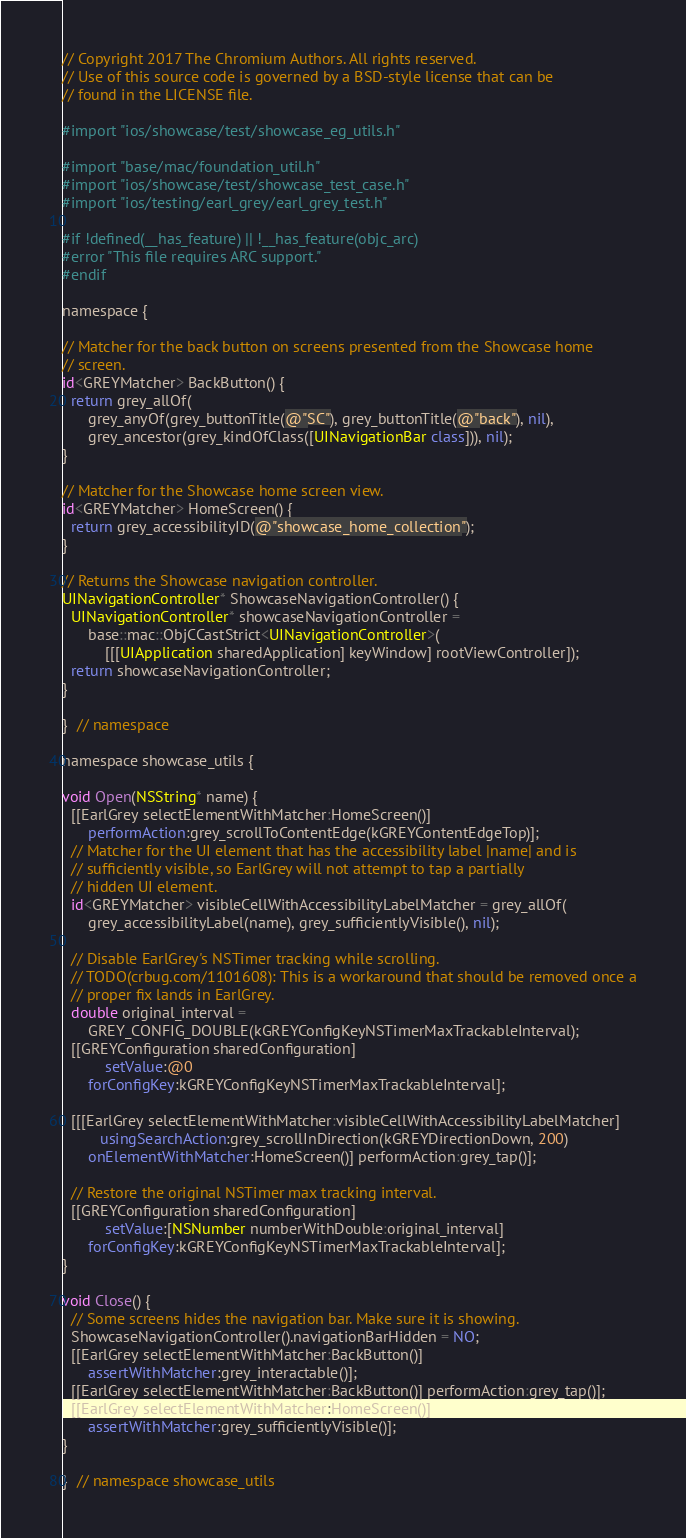<code> <loc_0><loc_0><loc_500><loc_500><_ObjectiveC_>// Copyright 2017 The Chromium Authors. All rights reserved.
// Use of this source code is governed by a BSD-style license that can be
// found in the LICENSE file.

#import "ios/showcase/test/showcase_eg_utils.h"

#import "base/mac/foundation_util.h"
#import "ios/showcase/test/showcase_test_case.h"
#import "ios/testing/earl_grey/earl_grey_test.h"

#if !defined(__has_feature) || !__has_feature(objc_arc)
#error "This file requires ARC support."
#endif

namespace {

// Matcher for the back button on screens presented from the Showcase home
// screen.
id<GREYMatcher> BackButton() {
  return grey_allOf(
      grey_anyOf(grey_buttonTitle(@"SC"), grey_buttonTitle(@"back"), nil),
      grey_ancestor(grey_kindOfClass([UINavigationBar class])), nil);
}

// Matcher for the Showcase home screen view.
id<GREYMatcher> HomeScreen() {
  return grey_accessibilityID(@"showcase_home_collection");
}

// Returns the Showcase navigation controller.
UINavigationController* ShowcaseNavigationController() {
  UINavigationController* showcaseNavigationController =
      base::mac::ObjCCastStrict<UINavigationController>(
          [[[UIApplication sharedApplication] keyWindow] rootViewController]);
  return showcaseNavigationController;
}

}  // namespace

namespace showcase_utils {

void Open(NSString* name) {
  [[EarlGrey selectElementWithMatcher:HomeScreen()]
      performAction:grey_scrollToContentEdge(kGREYContentEdgeTop)];
  // Matcher for the UI element that has the accessibility label |name| and is
  // sufficiently visible, so EarlGrey will not attempt to tap a partially
  // hidden UI element.
  id<GREYMatcher> visibleCellWithAccessibilityLabelMatcher = grey_allOf(
      grey_accessibilityLabel(name), grey_sufficientlyVisible(), nil);

  // Disable EarlGrey's NSTimer tracking while scrolling.
  // TODO(crbug.com/1101608): This is a workaround that should be removed once a
  // proper fix lands in EarlGrey.
  double original_interval =
      GREY_CONFIG_DOUBLE(kGREYConfigKeyNSTimerMaxTrackableInterval);
  [[GREYConfiguration sharedConfiguration]
          setValue:@0
      forConfigKey:kGREYConfigKeyNSTimerMaxTrackableInterval];

  [[[EarlGrey selectElementWithMatcher:visibleCellWithAccessibilityLabelMatcher]
         usingSearchAction:grey_scrollInDirection(kGREYDirectionDown, 200)
      onElementWithMatcher:HomeScreen()] performAction:grey_tap()];

  // Restore the original NSTimer max tracking interval.
  [[GREYConfiguration sharedConfiguration]
          setValue:[NSNumber numberWithDouble:original_interval]
      forConfigKey:kGREYConfigKeyNSTimerMaxTrackableInterval];
}

void Close() {
  // Some screens hides the navigation bar. Make sure it is showing.
  ShowcaseNavigationController().navigationBarHidden = NO;
  [[EarlGrey selectElementWithMatcher:BackButton()]
      assertWithMatcher:grey_interactable()];
  [[EarlGrey selectElementWithMatcher:BackButton()] performAction:grey_tap()];
  [[EarlGrey selectElementWithMatcher:HomeScreen()]
      assertWithMatcher:grey_sufficientlyVisible()];
}

}  // namespace showcase_utils
</code> 